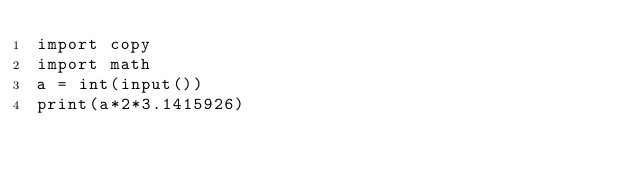<code> <loc_0><loc_0><loc_500><loc_500><_Python_>import copy
import math
a = int(input())
print(a*2*3.1415926)</code> 